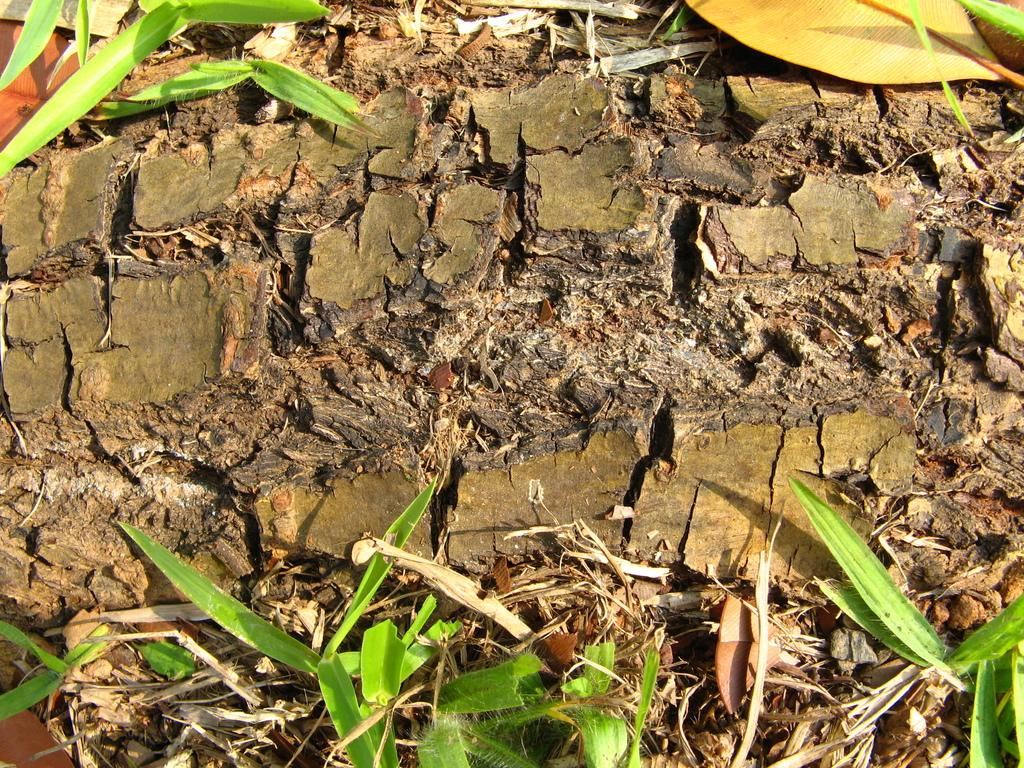What is covering the ground in the image? There are dried leaves and small plants on the ground. Can you describe the dried leaves in the image? The dried leaves are scattered on the ground. What type of plants are visible in the image? There are small plants on the ground. What color is the curtain hanging in the background of the image? There is no curtain present in the image; it only features dried leaves and small plants on the ground. 